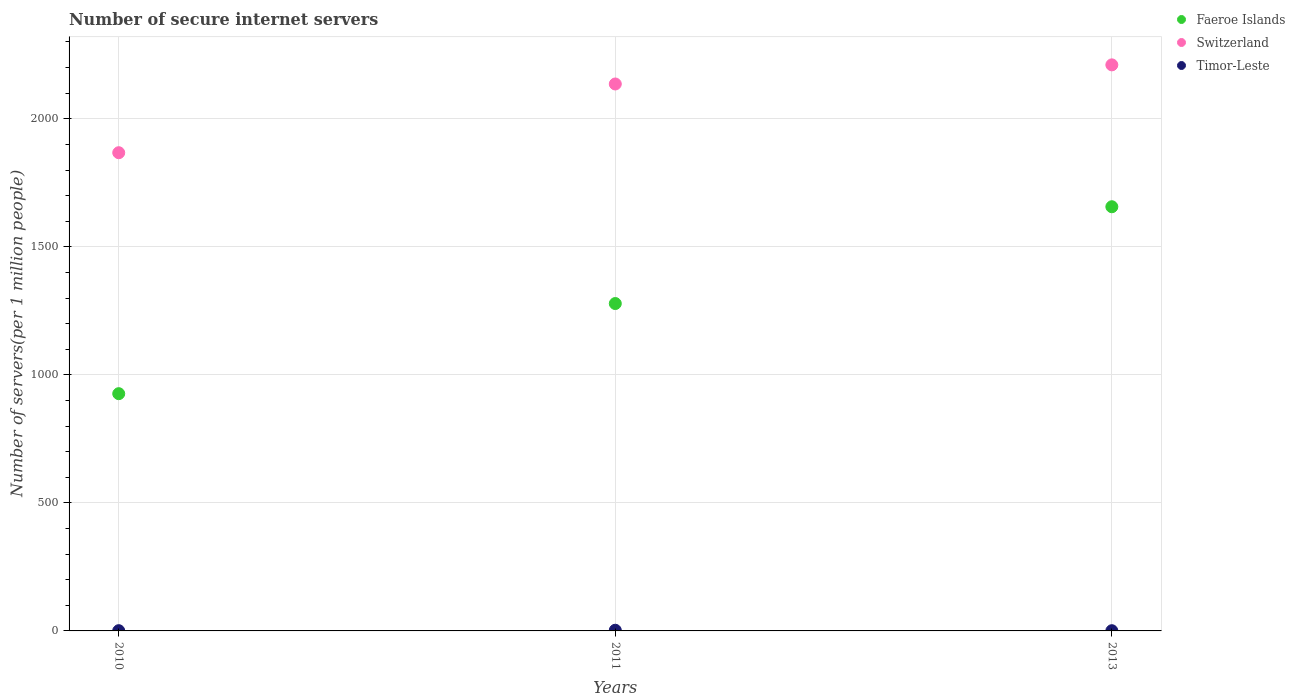How many different coloured dotlines are there?
Ensure brevity in your answer.  3. What is the number of secure internet servers in Switzerland in 2011?
Provide a short and direct response. 2136.01. Across all years, what is the maximum number of secure internet servers in Switzerland?
Provide a short and direct response. 2210.69. Across all years, what is the minimum number of secure internet servers in Faeroe Islands?
Give a very brief answer. 926.56. In which year was the number of secure internet servers in Faeroe Islands maximum?
Keep it short and to the point. 2013. What is the total number of secure internet servers in Timor-Leste in the graph?
Your answer should be compact. 4.46. What is the difference between the number of secure internet servers in Switzerland in 2011 and that in 2013?
Your answer should be very brief. -74.67. What is the difference between the number of secure internet servers in Switzerland in 2013 and the number of secure internet servers in Timor-Leste in 2010?
Offer a very short reply. 2209.75. What is the average number of secure internet servers in Switzerland per year?
Make the answer very short. 2071.44. In the year 2011, what is the difference between the number of secure internet servers in Timor-Leste and number of secure internet servers in Faeroe Islands?
Make the answer very short. -1275.88. In how many years, is the number of secure internet servers in Faeroe Islands greater than 1100?
Provide a short and direct response. 2. What is the ratio of the number of secure internet servers in Switzerland in 2011 to that in 2013?
Provide a succinct answer. 0.97. What is the difference between the highest and the second highest number of secure internet servers in Switzerland?
Offer a terse response. 74.67. What is the difference between the highest and the lowest number of secure internet servers in Faeroe Islands?
Offer a very short reply. 730.03. In how many years, is the number of secure internet servers in Switzerland greater than the average number of secure internet servers in Switzerland taken over all years?
Give a very brief answer. 2. Does the number of secure internet servers in Faeroe Islands monotonically increase over the years?
Ensure brevity in your answer.  Yes. Is the number of secure internet servers in Switzerland strictly greater than the number of secure internet servers in Faeroe Islands over the years?
Provide a short and direct response. Yes. Is the number of secure internet servers in Switzerland strictly less than the number of secure internet servers in Faeroe Islands over the years?
Offer a terse response. No. Does the graph contain any zero values?
Provide a short and direct response. No. Does the graph contain grids?
Provide a succinct answer. Yes. Where does the legend appear in the graph?
Provide a short and direct response. Top right. How many legend labels are there?
Provide a succinct answer. 3. How are the legend labels stacked?
Provide a succinct answer. Vertical. What is the title of the graph?
Make the answer very short. Number of secure internet servers. Does "Israel" appear as one of the legend labels in the graph?
Offer a terse response. No. What is the label or title of the X-axis?
Your answer should be compact. Years. What is the label or title of the Y-axis?
Your response must be concise. Number of servers(per 1 million people). What is the Number of servers(per 1 million people) in Faeroe Islands in 2010?
Provide a succinct answer. 926.56. What is the Number of servers(per 1 million people) of Switzerland in 2010?
Give a very brief answer. 1867.63. What is the Number of servers(per 1 million people) in Timor-Leste in 2010?
Your answer should be very brief. 0.94. What is the Number of servers(per 1 million people) in Faeroe Islands in 2011?
Offer a very short reply. 1278.56. What is the Number of servers(per 1 million people) of Switzerland in 2011?
Provide a succinct answer. 2136.01. What is the Number of servers(per 1 million people) in Timor-Leste in 2011?
Your answer should be very brief. 2.68. What is the Number of servers(per 1 million people) in Faeroe Islands in 2013?
Offer a terse response. 1656.59. What is the Number of servers(per 1 million people) in Switzerland in 2013?
Keep it short and to the point. 2210.69. What is the Number of servers(per 1 million people) in Timor-Leste in 2013?
Provide a short and direct response. 0.85. Across all years, what is the maximum Number of servers(per 1 million people) of Faeroe Islands?
Ensure brevity in your answer.  1656.59. Across all years, what is the maximum Number of servers(per 1 million people) in Switzerland?
Your answer should be very brief. 2210.69. Across all years, what is the maximum Number of servers(per 1 million people) of Timor-Leste?
Your answer should be very brief. 2.68. Across all years, what is the minimum Number of servers(per 1 million people) of Faeroe Islands?
Keep it short and to the point. 926.56. Across all years, what is the minimum Number of servers(per 1 million people) of Switzerland?
Your answer should be compact. 1867.63. Across all years, what is the minimum Number of servers(per 1 million people) in Timor-Leste?
Your answer should be compact. 0.85. What is the total Number of servers(per 1 million people) of Faeroe Islands in the graph?
Offer a very short reply. 3861.71. What is the total Number of servers(per 1 million people) of Switzerland in the graph?
Offer a very short reply. 6214.33. What is the total Number of servers(per 1 million people) in Timor-Leste in the graph?
Provide a succinct answer. 4.46. What is the difference between the Number of servers(per 1 million people) of Faeroe Islands in 2010 and that in 2011?
Provide a succinct answer. -352.01. What is the difference between the Number of servers(per 1 million people) of Switzerland in 2010 and that in 2011?
Give a very brief answer. -268.39. What is the difference between the Number of servers(per 1 million people) of Timor-Leste in 2010 and that in 2011?
Keep it short and to the point. -1.74. What is the difference between the Number of servers(per 1 million people) in Faeroe Islands in 2010 and that in 2013?
Your answer should be very brief. -730.03. What is the difference between the Number of servers(per 1 million people) in Switzerland in 2010 and that in 2013?
Keep it short and to the point. -343.06. What is the difference between the Number of servers(per 1 million people) in Timor-Leste in 2010 and that in 2013?
Give a very brief answer. 0.09. What is the difference between the Number of servers(per 1 million people) of Faeroe Islands in 2011 and that in 2013?
Your response must be concise. -378.03. What is the difference between the Number of servers(per 1 million people) in Switzerland in 2011 and that in 2013?
Offer a terse response. -74.67. What is the difference between the Number of servers(per 1 million people) in Timor-Leste in 2011 and that in 2013?
Your answer should be very brief. 1.83. What is the difference between the Number of servers(per 1 million people) in Faeroe Islands in 2010 and the Number of servers(per 1 million people) in Switzerland in 2011?
Your answer should be compact. -1209.46. What is the difference between the Number of servers(per 1 million people) of Faeroe Islands in 2010 and the Number of servers(per 1 million people) of Timor-Leste in 2011?
Offer a very short reply. 923.88. What is the difference between the Number of servers(per 1 million people) in Switzerland in 2010 and the Number of servers(per 1 million people) in Timor-Leste in 2011?
Your answer should be compact. 1864.95. What is the difference between the Number of servers(per 1 million people) in Faeroe Islands in 2010 and the Number of servers(per 1 million people) in Switzerland in 2013?
Provide a succinct answer. -1284.13. What is the difference between the Number of servers(per 1 million people) of Faeroe Islands in 2010 and the Number of servers(per 1 million people) of Timor-Leste in 2013?
Give a very brief answer. 925.71. What is the difference between the Number of servers(per 1 million people) of Switzerland in 2010 and the Number of servers(per 1 million people) of Timor-Leste in 2013?
Make the answer very short. 1866.78. What is the difference between the Number of servers(per 1 million people) in Faeroe Islands in 2011 and the Number of servers(per 1 million people) in Switzerland in 2013?
Your response must be concise. -932.12. What is the difference between the Number of servers(per 1 million people) of Faeroe Islands in 2011 and the Number of servers(per 1 million people) of Timor-Leste in 2013?
Your answer should be very brief. 1277.71. What is the difference between the Number of servers(per 1 million people) of Switzerland in 2011 and the Number of servers(per 1 million people) of Timor-Leste in 2013?
Ensure brevity in your answer.  2135.17. What is the average Number of servers(per 1 million people) in Faeroe Islands per year?
Your answer should be compact. 1287.24. What is the average Number of servers(per 1 million people) in Switzerland per year?
Keep it short and to the point. 2071.44. What is the average Number of servers(per 1 million people) in Timor-Leste per year?
Your answer should be compact. 1.49. In the year 2010, what is the difference between the Number of servers(per 1 million people) in Faeroe Islands and Number of servers(per 1 million people) in Switzerland?
Ensure brevity in your answer.  -941.07. In the year 2010, what is the difference between the Number of servers(per 1 million people) of Faeroe Islands and Number of servers(per 1 million people) of Timor-Leste?
Your response must be concise. 925.62. In the year 2010, what is the difference between the Number of servers(per 1 million people) of Switzerland and Number of servers(per 1 million people) of Timor-Leste?
Your answer should be compact. 1866.69. In the year 2011, what is the difference between the Number of servers(per 1 million people) in Faeroe Islands and Number of servers(per 1 million people) in Switzerland?
Provide a succinct answer. -857.45. In the year 2011, what is the difference between the Number of servers(per 1 million people) of Faeroe Islands and Number of servers(per 1 million people) of Timor-Leste?
Offer a very short reply. 1275.88. In the year 2011, what is the difference between the Number of servers(per 1 million people) of Switzerland and Number of servers(per 1 million people) of Timor-Leste?
Your answer should be compact. 2133.34. In the year 2013, what is the difference between the Number of servers(per 1 million people) of Faeroe Islands and Number of servers(per 1 million people) of Switzerland?
Offer a very short reply. -554.1. In the year 2013, what is the difference between the Number of servers(per 1 million people) in Faeroe Islands and Number of servers(per 1 million people) in Timor-Leste?
Give a very brief answer. 1655.74. In the year 2013, what is the difference between the Number of servers(per 1 million people) of Switzerland and Number of servers(per 1 million people) of Timor-Leste?
Provide a short and direct response. 2209.84. What is the ratio of the Number of servers(per 1 million people) of Faeroe Islands in 2010 to that in 2011?
Provide a succinct answer. 0.72. What is the ratio of the Number of servers(per 1 million people) of Switzerland in 2010 to that in 2011?
Your answer should be very brief. 0.87. What is the ratio of the Number of servers(per 1 million people) of Timor-Leste in 2010 to that in 2011?
Ensure brevity in your answer.  0.35. What is the ratio of the Number of servers(per 1 million people) in Faeroe Islands in 2010 to that in 2013?
Give a very brief answer. 0.56. What is the ratio of the Number of servers(per 1 million people) of Switzerland in 2010 to that in 2013?
Give a very brief answer. 0.84. What is the ratio of the Number of servers(per 1 million people) in Timor-Leste in 2010 to that in 2013?
Offer a very short reply. 1.11. What is the ratio of the Number of servers(per 1 million people) in Faeroe Islands in 2011 to that in 2013?
Provide a succinct answer. 0.77. What is the ratio of the Number of servers(per 1 million people) in Switzerland in 2011 to that in 2013?
Your response must be concise. 0.97. What is the ratio of the Number of servers(per 1 million people) of Timor-Leste in 2011 to that in 2013?
Offer a very short reply. 3.16. What is the difference between the highest and the second highest Number of servers(per 1 million people) in Faeroe Islands?
Give a very brief answer. 378.03. What is the difference between the highest and the second highest Number of servers(per 1 million people) of Switzerland?
Give a very brief answer. 74.67. What is the difference between the highest and the second highest Number of servers(per 1 million people) of Timor-Leste?
Keep it short and to the point. 1.74. What is the difference between the highest and the lowest Number of servers(per 1 million people) in Faeroe Islands?
Your answer should be compact. 730.03. What is the difference between the highest and the lowest Number of servers(per 1 million people) of Switzerland?
Offer a terse response. 343.06. What is the difference between the highest and the lowest Number of servers(per 1 million people) in Timor-Leste?
Your answer should be compact. 1.83. 